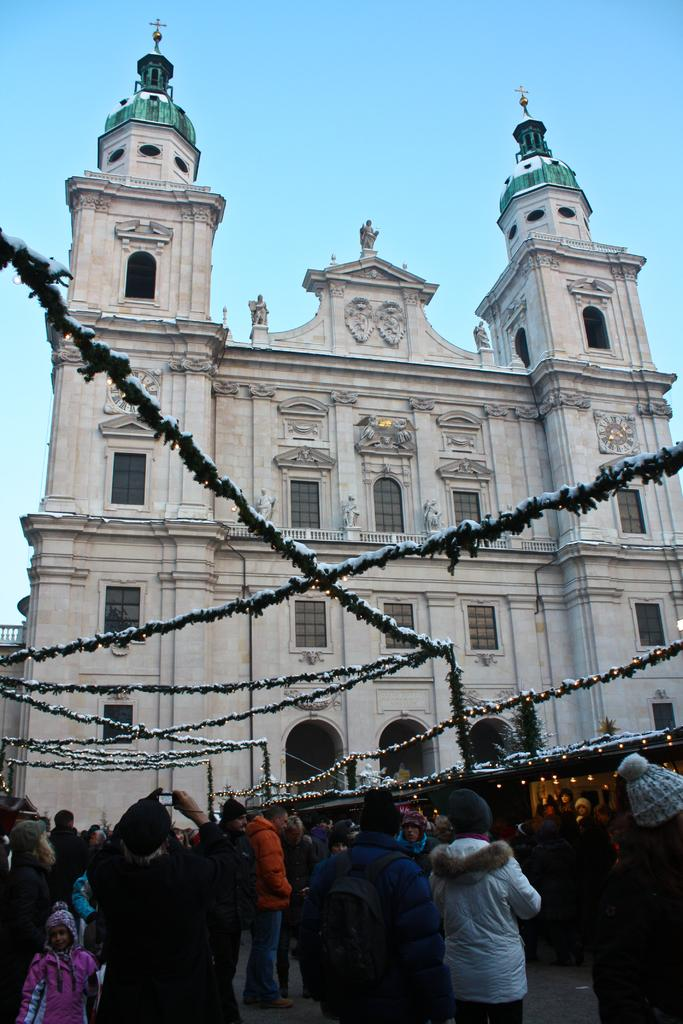What are the people in the image doing? The people in the image are standing on a road. What can be seen at the top of the image? There are lights at the top of the image. What is visible in the background of the image? There is a church in the background of the image. What is visible in the sky in the image? The sky is visible in the image. What type of sleet can be seen falling from the sky in the image? There is no sleet visible in the image; the sky is simply visible. What type of class is being held in the church in the image? There is no indication of a class being held in the church in the image, as it is only visible in the background. 